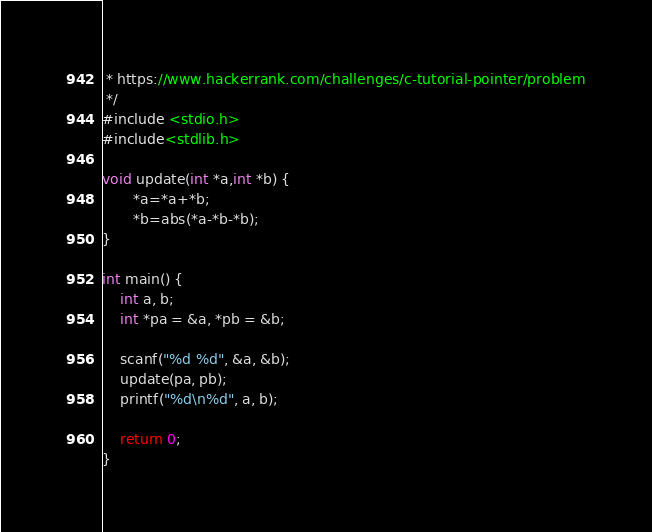<code> <loc_0><loc_0><loc_500><loc_500><_C++_> * https://www.hackerrank.com/challenges/c-tutorial-pointer/problem
 */
#include <stdio.h>
#include<stdlib.h>

void update(int *a,int *b) {
       *a=*a+*b;
       *b=abs(*a-*b-*b);
}

int main() {
    int a, b;
    int *pa = &a, *pb = &b;

    scanf("%d %d", &a, &b);
    update(pa, pb);
    printf("%d\n%d", a, b);

    return 0;
}


</code> 